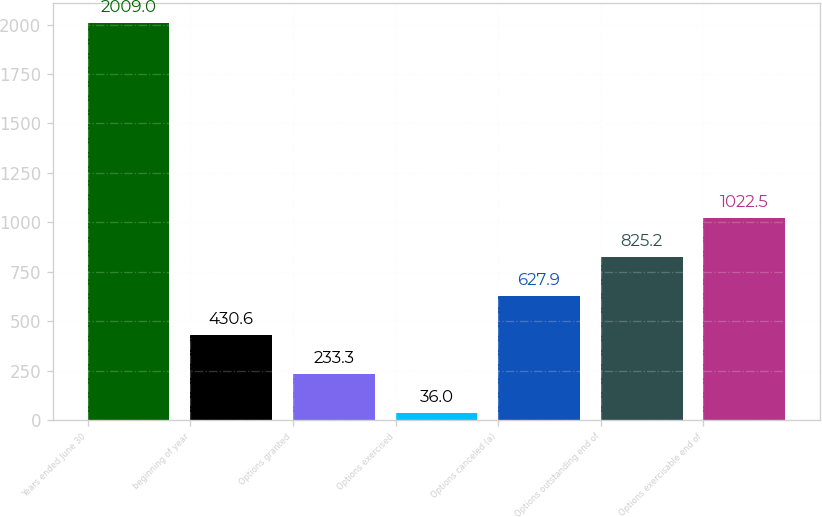<chart> <loc_0><loc_0><loc_500><loc_500><bar_chart><fcel>Years ended June 30<fcel>beginning of year<fcel>Options granted<fcel>Options exercised<fcel>Options canceled (a)<fcel>Options outstanding end of<fcel>Options exercisable end of<nl><fcel>2009<fcel>430.6<fcel>233.3<fcel>36<fcel>627.9<fcel>825.2<fcel>1022.5<nl></chart> 